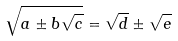<formula> <loc_0><loc_0><loc_500><loc_500>\sqrt { a \pm b \sqrt { c } } = \sqrt { d } \pm \sqrt { e }</formula> 